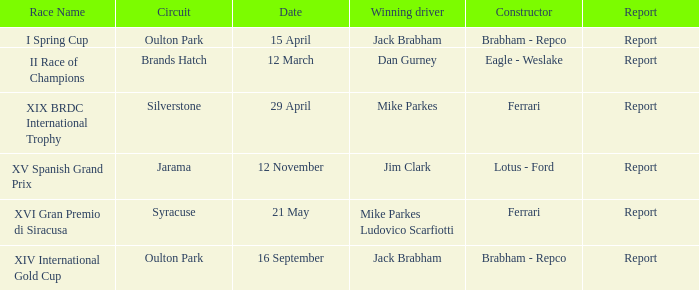What date was the xiv international gold cup? 16 September. 